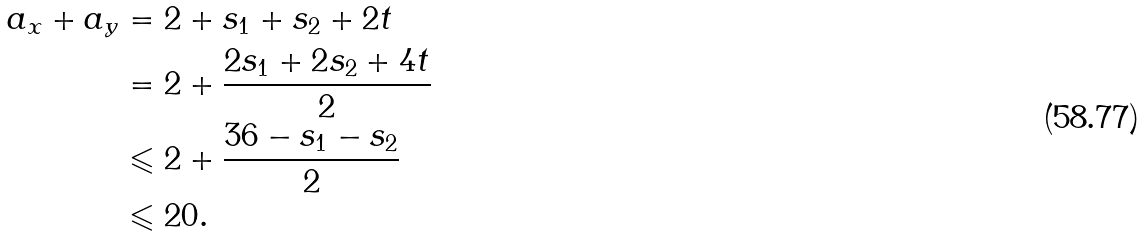<formula> <loc_0><loc_0><loc_500><loc_500>a _ { x } + a _ { y } & = 2 + s _ { 1 } + s _ { 2 } + 2 t \\ & = 2 + \frac { 2 s _ { 1 } + 2 s _ { 2 } + 4 t } { 2 } \\ & \leqslant 2 + \frac { 3 6 - s _ { 1 } - s _ { 2 } } { 2 } \\ & \leqslant 2 0 .</formula> 